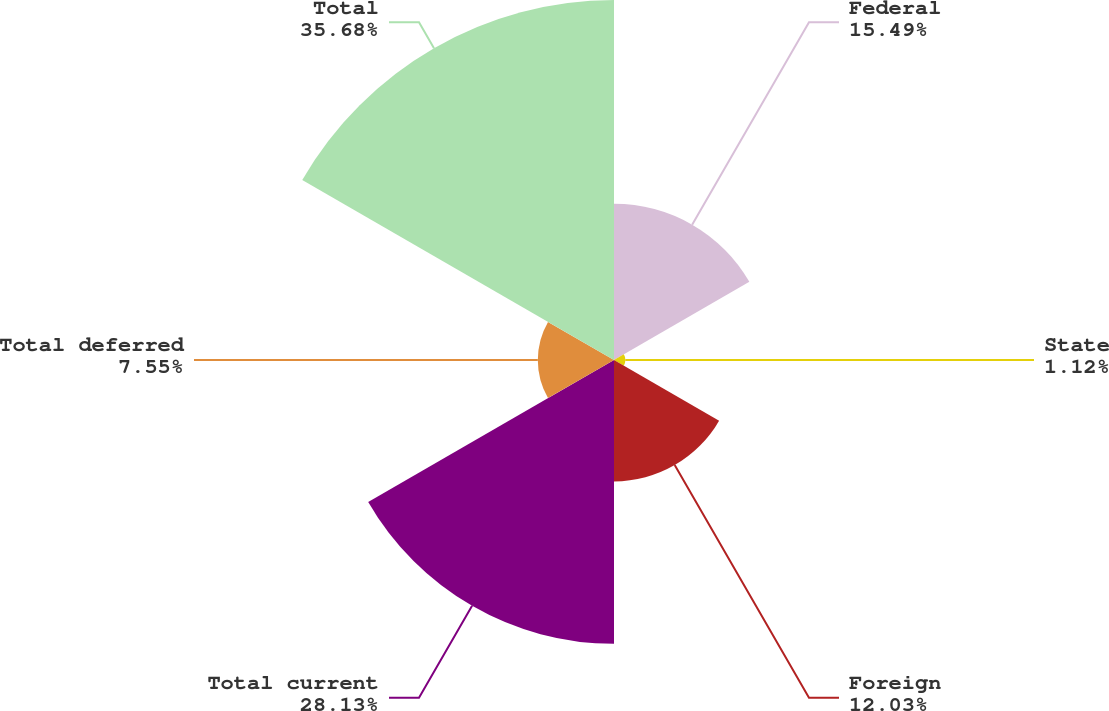Convert chart. <chart><loc_0><loc_0><loc_500><loc_500><pie_chart><fcel>Federal<fcel>State<fcel>Foreign<fcel>Total current<fcel>Total deferred<fcel>Total<nl><fcel>15.49%<fcel>1.12%<fcel>12.03%<fcel>28.13%<fcel>7.55%<fcel>35.68%<nl></chart> 